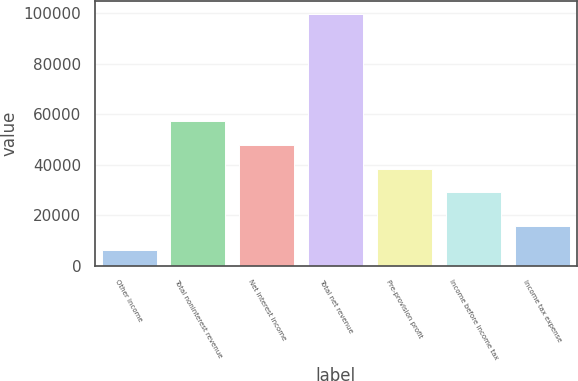<chart> <loc_0><loc_0><loc_500><loc_500><bar_chart><fcel>Other income<fcel>Total noninterest revenue<fcel>Net interest income<fcel>Total net revenue<fcel>Pre-provision profit<fcel>Income before income tax<fcel>Income tax expense<nl><fcel>6342<fcel>57142.8<fcel>47797.2<fcel>99798<fcel>38451.6<fcel>29106<fcel>15687.6<nl></chart> 